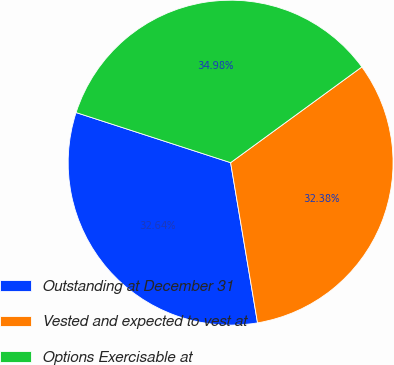Convert chart to OTSL. <chart><loc_0><loc_0><loc_500><loc_500><pie_chart><fcel>Outstanding at December 31<fcel>Vested and expected to vest at<fcel>Options Exercisable at<nl><fcel>32.64%<fcel>32.38%<fcel>34.98%<nl></chart> 